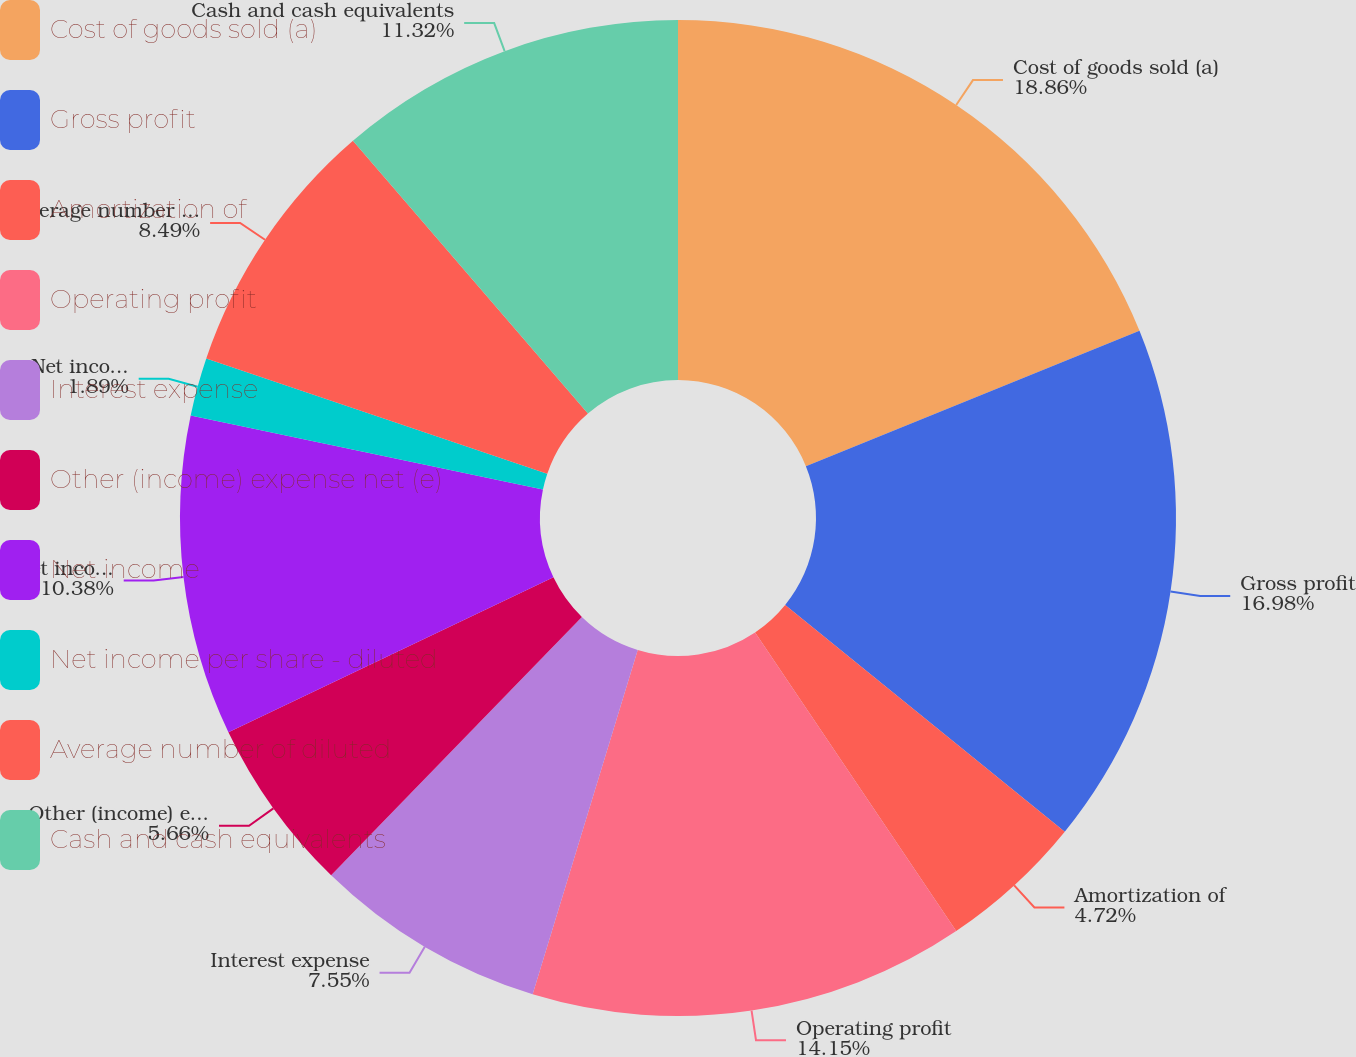Convert chart. <chart><loc_0><loc_0><loc_500><loc_500><pie_chart><fcel>Cost of goods sold (a)<fcel>Gross profit<fcel>Amortization of<fcel>Operating profit<fcel>Interest expense<fcel>Other (income) expense net (e)<fcel>Net income<fcel>Net income per share - diluted<fcel>Average number of diluted<fcel>Cash and cash equivalents<nl><fcel>18.87%<fcel>16.98%<fcel>4.72%<fcel>14.15%<fcel>7.55%<fcel>5.66%<fcel>10.38%<fcel>1.89%<fcel>8.49%<fcel>11.32%<nl></chart> 